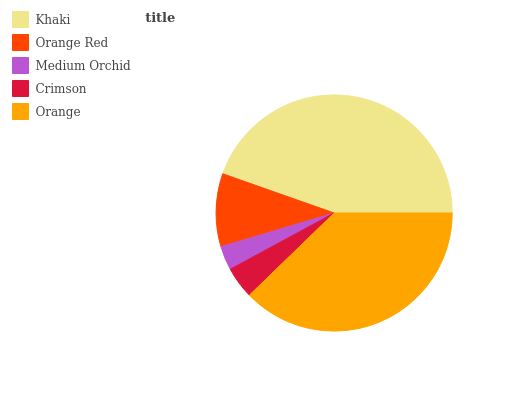Is Medium Orchid the minimum?
Answer yes or no. Yes. Is Khaki the maximum?
Answer yes or no. Yes. Is Orange Red the minimum?
Answer yes or no. No. Is Orange Red the maximum?
Answer yes or no. No. Is Khaki greater than Orange Red?
Answer yes or no. Yes. Is Orange Red less than Khaki?
Answer yes or no. Yes. Is Orange Red greater than Khaki?
Answer yes or no. No. Is Khaki less than Orange Red?
Answer yes or no. No. Is Orange Red the high median?
Answer yes or no. Yes. Is Orange Red the low median?
Answer yes or no. Yes. Is Orange the high median?
Answer yes or no. No. Is Medium Orchid the low median?
Answer yes or no. No. 